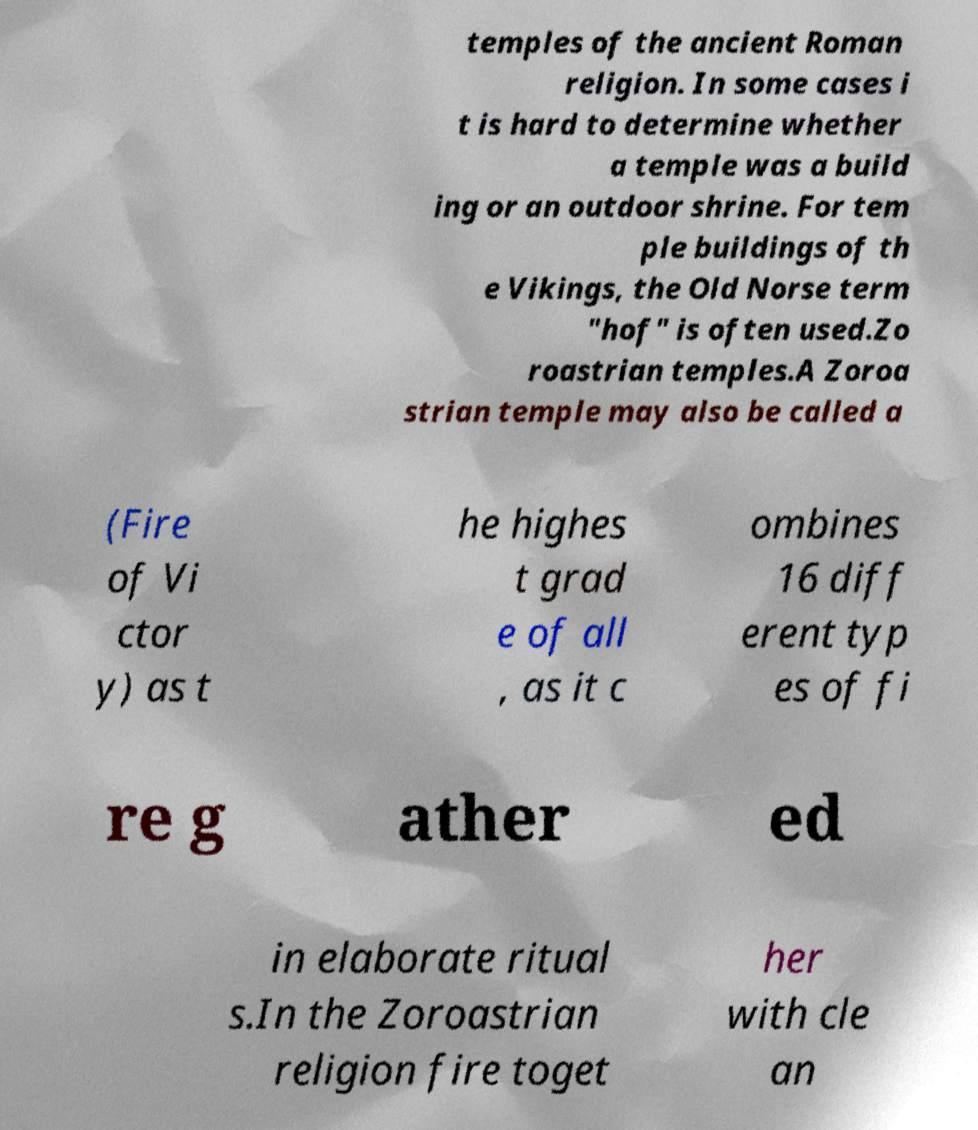I need the written content from this picture converted into text. Can you do that? temples of the ancient Roman religion. In some cases i t is hard to determine whether a temple was a build ing or an outdoor shrine. For tem ple buildings of th e Vikings, the Old Norse term "hof" is often used.Zo roastrian temples.A Zoroa strian temple may also be called a (Fire of Vi ctor y) as t he highes t grad e of all , as it c ombines 16 diff erent typ es of fi re g ather ed in elaborate ritual s.In the Zoroastrian religion fire toget her with cle an 